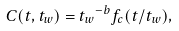<formula> <loc_0><loc_0><loc_500><loc_500>C ( t , t _ { w } ) = { t _ { w } } ^ { - b } f _ { c } ( t / t _ { w } ) ,</formula> 